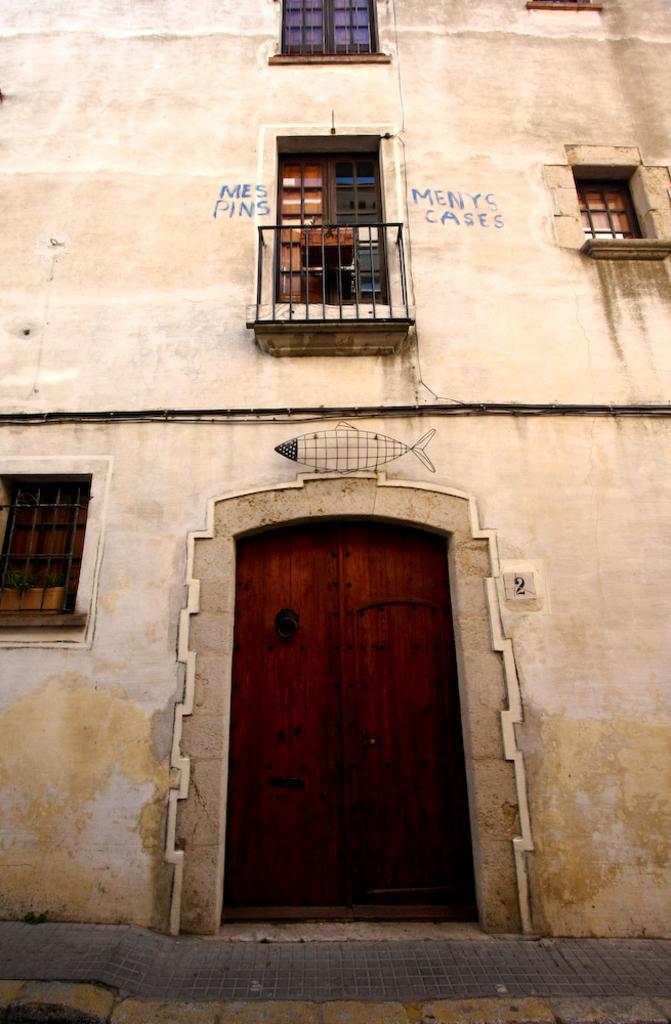How would you summarize this image in a sentence or two? This is a zoom-in picture of a building where we can see a door and windows. 